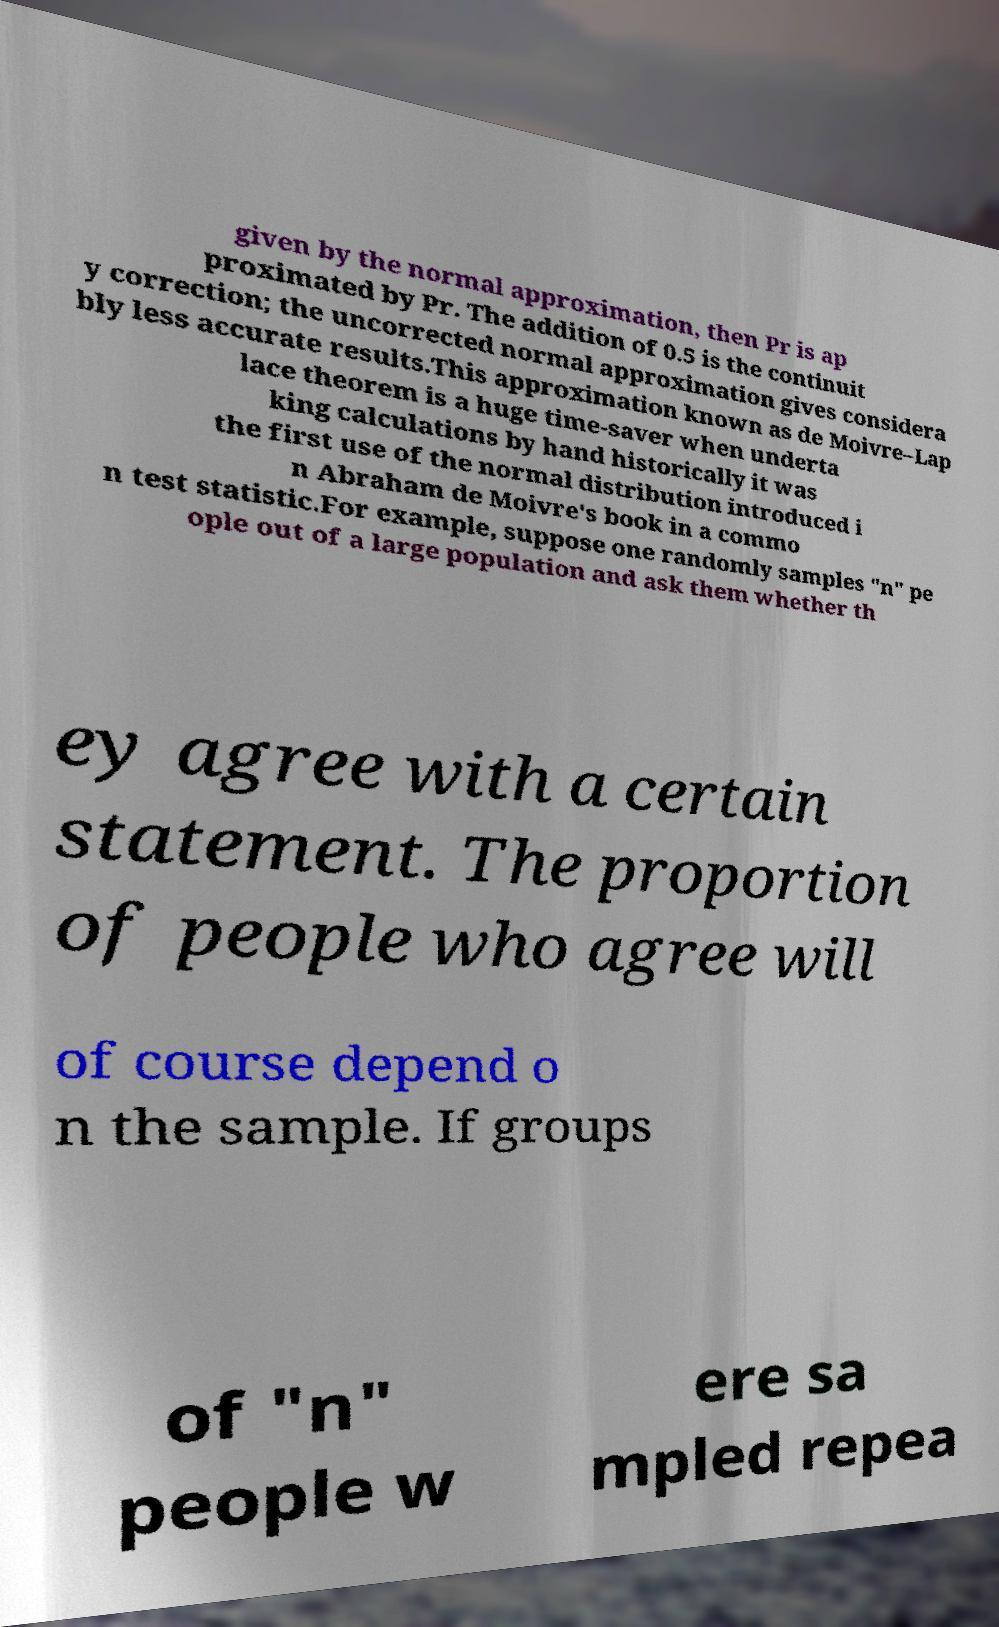There's text embedded in this image that I need extracted. Can you transcribe it verbatim? given by the normal approximation, then Pr is ap proximated by Pr. The addition of 0.5 is the continuit y correction; the uncorrected normal approximation gives considera bly less accurate results.This approximation known as de Moivre–Lap lace theorem is a huge time-saver when underta king calculations by hand historically it was the first use of the normal distribution introduced i n Abraham de Moivre's book in a commo n test statistic.For example, suppose one randomly samples "n" pe ople out of a large population and ask them whether th ey agree with a certain statement. The proportion of people who agree will of course depend o n the sample. If groups of "n" people w ere sa mpled repea 